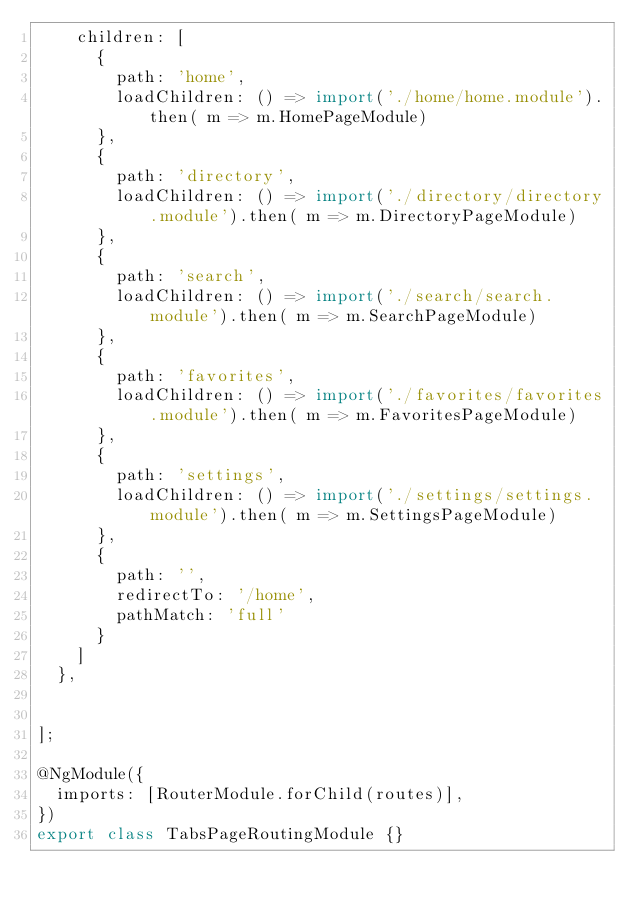Convert code to text. <code><loc_0><loc_0><loc_500><loc_500><_TypeScript_>    children: [
      {
        path: 'home',
        loadChildren: () => import('./home/home.module').then( m => m.HomePageModule)
      },
      {
        path: 'directory',
        loadChildren: () => import('./directory/directory.module').then( m => m.DirectoryPageModule)
      },
      {
        path: 'search',
        loadChildren: () => import('./search/search.module').then( m => m.SearchPageModule)
      },
      {
        path: 'favorites',
        loadChildren: () => import('./favorites/favorites.module').then( m => m.FavoritesPageModule)
      },
      {
        path: 'settings',
        loadChildren: () => import('./settings/settings.module').then( m => m.SettingsPageModule)
      },
      {
        path: '',
        redirectTo: '/home',
        pathMatch: 'full'
      }
    ]
  },


];

@NgModule({
  imports: [RouterModule.forChild(routes)],
})
export class TabsPageRoutingModule {}
</code> 